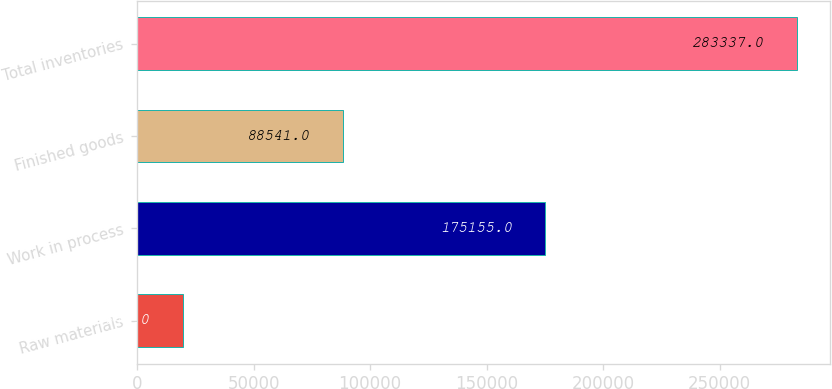Convert chart to OTSL. <chart><loc_0><loc_0><loc_500><loc_500><bar_chart><fcel>Raw materials<fcel>Work in process<fcel>Finished goods<fcel>Total inventories<nl><fcel>19641<fcel>175155<fcel>88541<fcel>283337<nl></chart> 